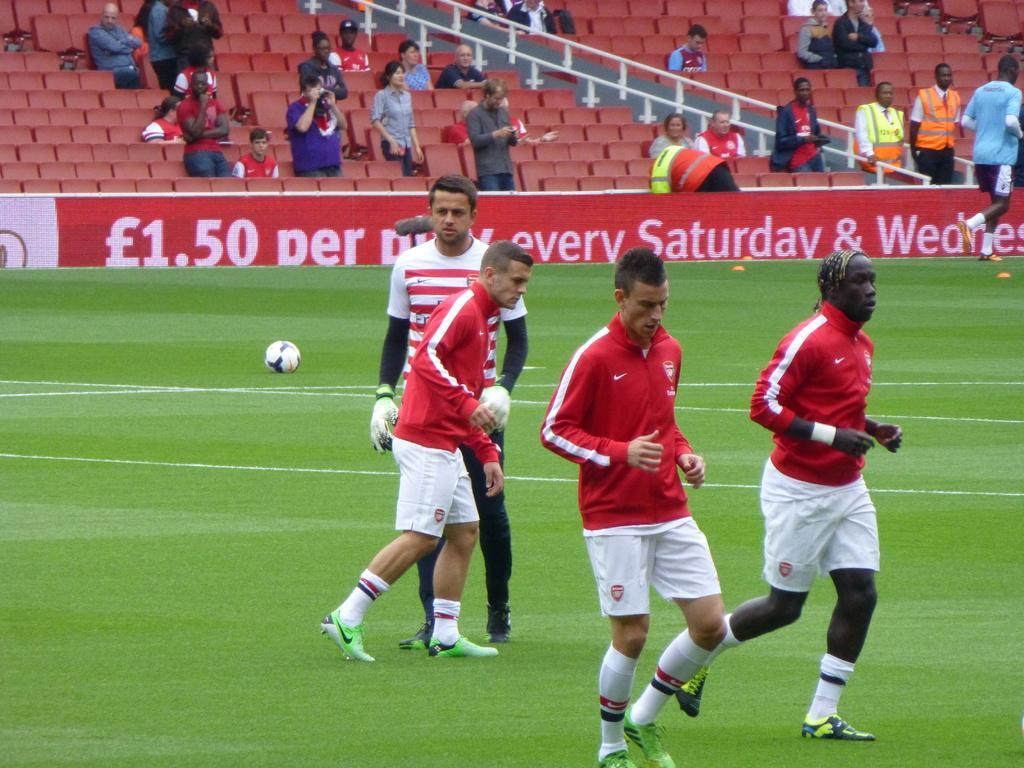<image>
Relay a brief, clear account of the picture shown. Four soccer players with a sign in the back that says L1.50 in the background. 